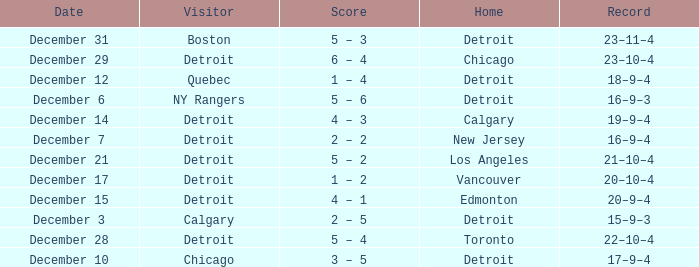What is the planned date for the home team detroit and the guest chicago? December 10. 